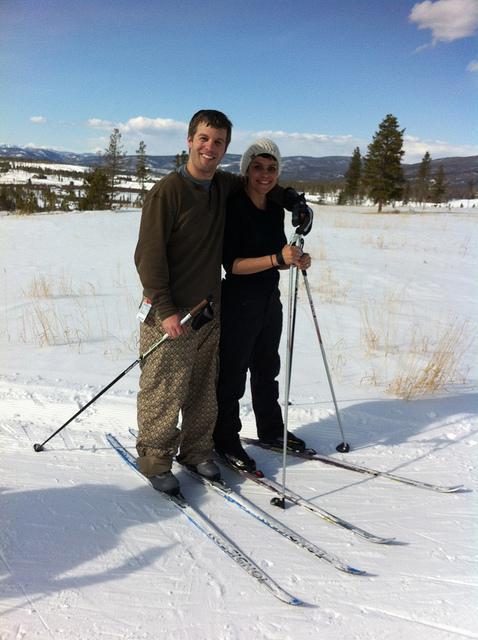How many ski can be seen?
Give a very brief answer. 2. How many people are there?
Give a very brief answer. 2. 